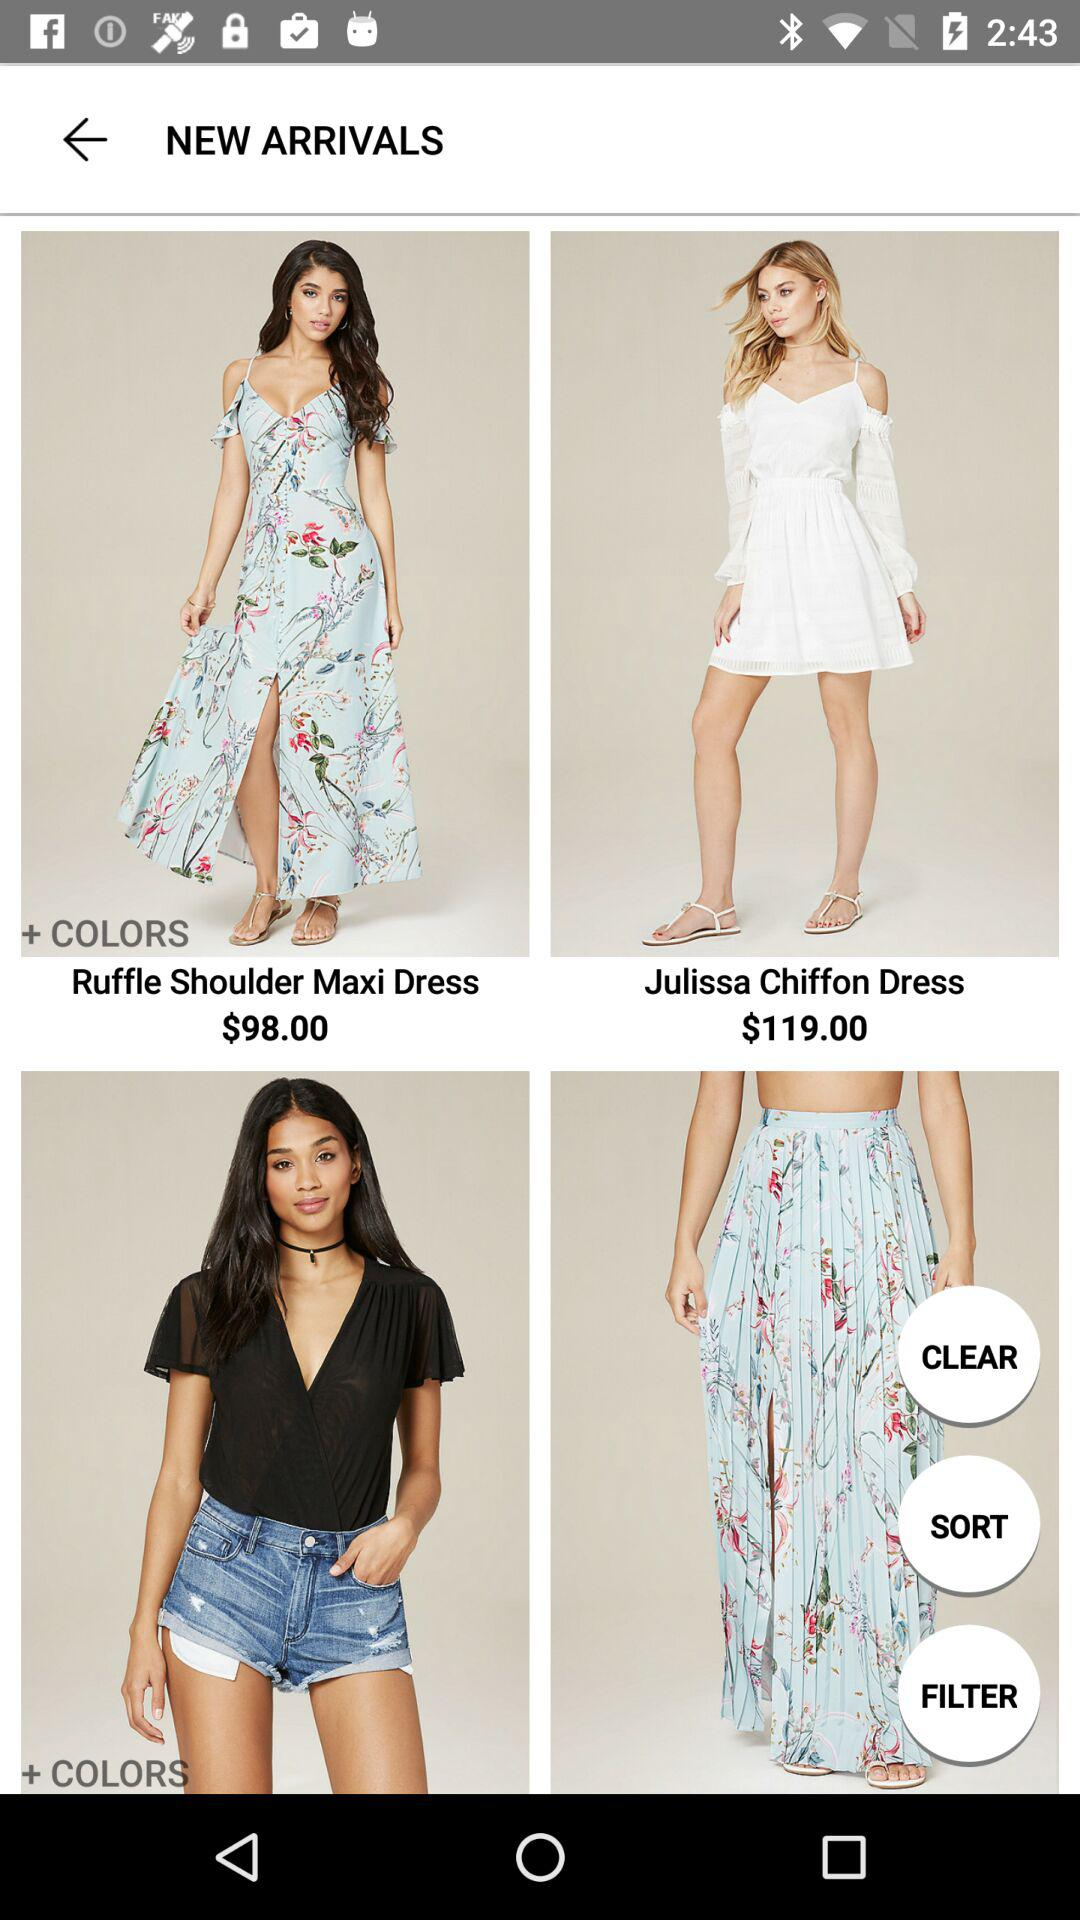How much more does the Julissa Chiffon Dress cost than the Ruffle Shoulder Maxi Dress?
Answer the question using a single word or phrase. $21.00 